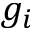Convert formula to latex. <formula><loc_0><loc_0><loc_500><loc_500>g _ { i }</formula> 